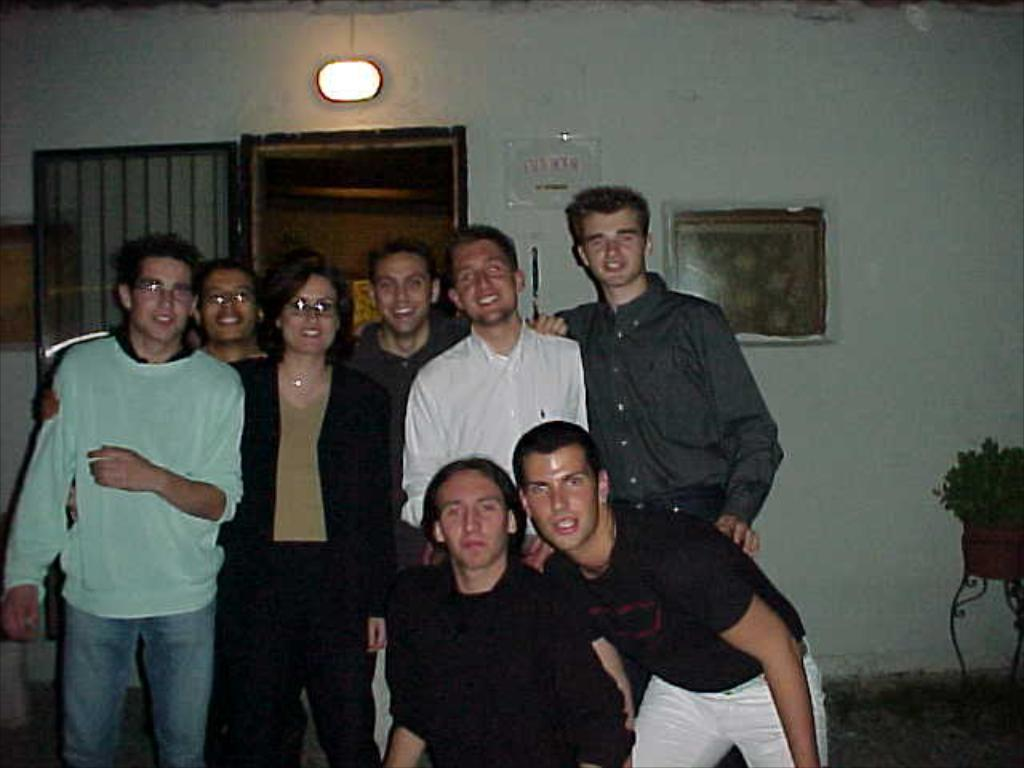What are the people in the image doing? The people in the image are standing and smiling. What can be seen on the wall in the background? There is a photo frame on the wall in the background. What architectural features are visible in the background? There is a door and a light in the background. What type of decorative item is present in the background? There is a flower pot in the background. What type of bike is leaning against the door in the image? There is no bike present in the image; it only features people, a photo frame, a door, a light, and a flower pot. 